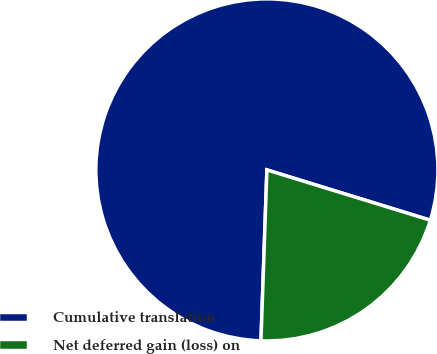Convert chart to OTSL. <chart><loc_0><loc_0><loc_500><loc_500><pie_chart><fcel>Cumulative translation<fcel>Net deferred gain (loss) on<nl><fcel>79.2%<fcel>20.8%<nl></chart> 